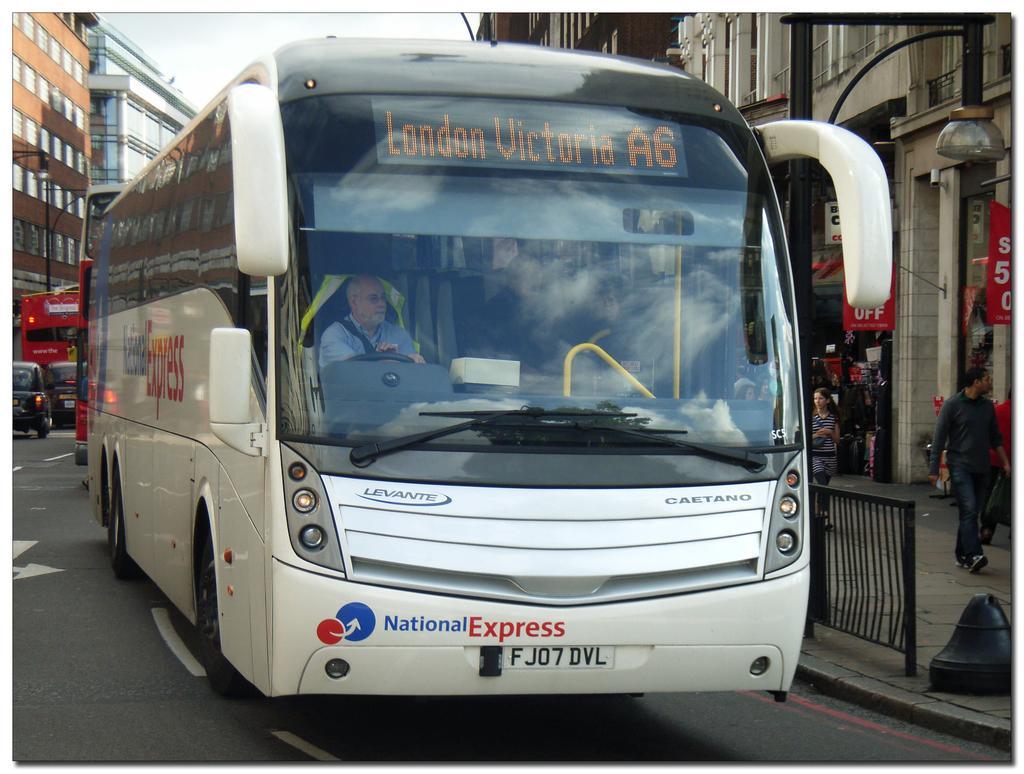How would you summarize this image in a sentence or two? In the picture we can see a bus on the road and in the bus we can see a man sitting and driving it and on the top of the bus we can see a name London Victoria A6 and beside the bus we can see a railing on the path and behind it we can see some people are walking near to the shops which are to the buildings and behind the bus we can see some vehicles on the road and behind it we can see some buildings with windows and behind it we can see a sky. 